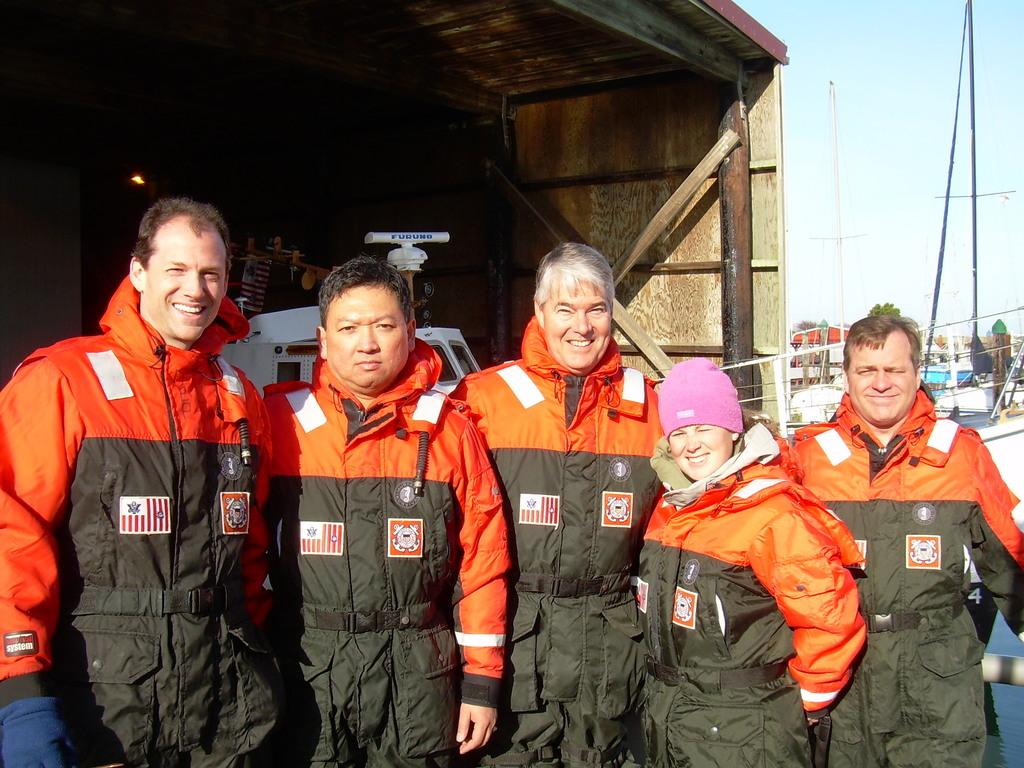What can be observed about the people in the image? There are people standing in the image, and they are wearing orange and green color dresses. What is visible in the background of the image? There is a shed visible in the background, along with other objects. How would you describe the color of the sky in the image? The sky is blue and white in color. Can you see any ice on the ground in the image? There is no ice visible on the ground in the image. Is there a bat flying in the sky in the image? There is no bat present in the image; only people, a shed, and the sky are visible. 